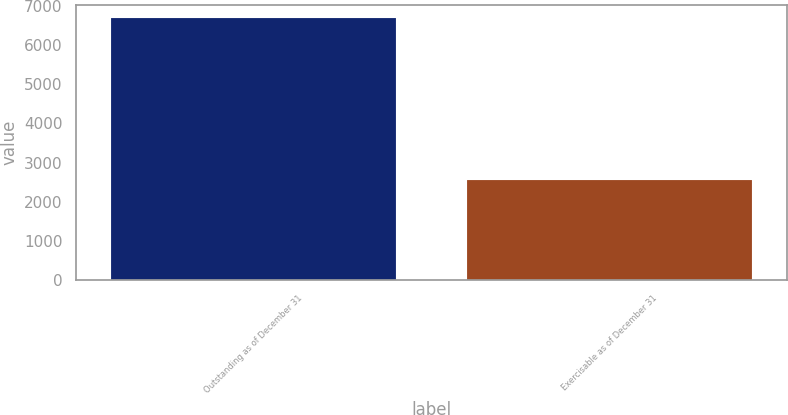Convert chart to OTSL. <chart><loc_0><loc_0><loc_500><loc_500><bar_chart><fcel>Outstanding as of December 31<fcel>Exercisable as of December 31<nl><fcel>6686<fcel>2547<nl></chart> 